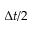Convert formula to latex. <formula><loc_0><loc_0><loc_500><loc_500>\Delta t / 2</formula> 